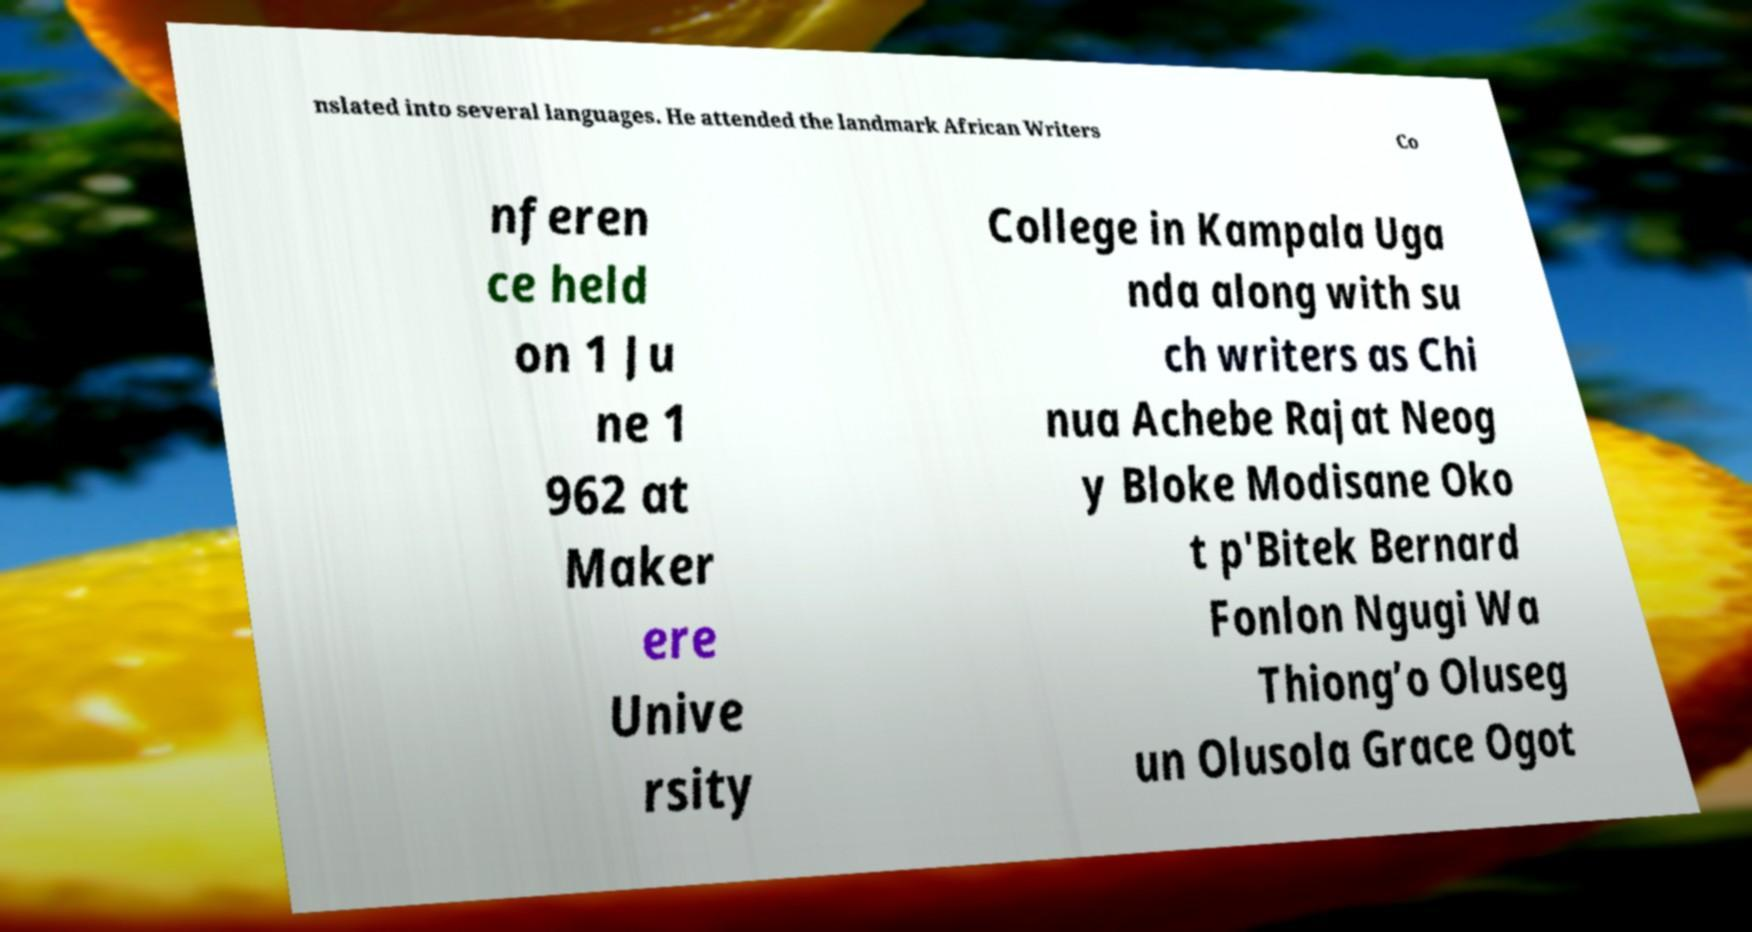Please read and relay the text visible in this image. What does it say? nslated into several languages. He attended the landmark African Writers Co nferen ce held on 1 Ju ne 1 962 at Maker ere Unive rsity College in Kampala Uga nda along with su ch writers as Chi nua Achebe Rajat Neog y Bloke Modisane Oko t p'Bitek Bernard Fonlon Ngugi Wa Thiong’o Oluseg un Olusola Grace Ogot 